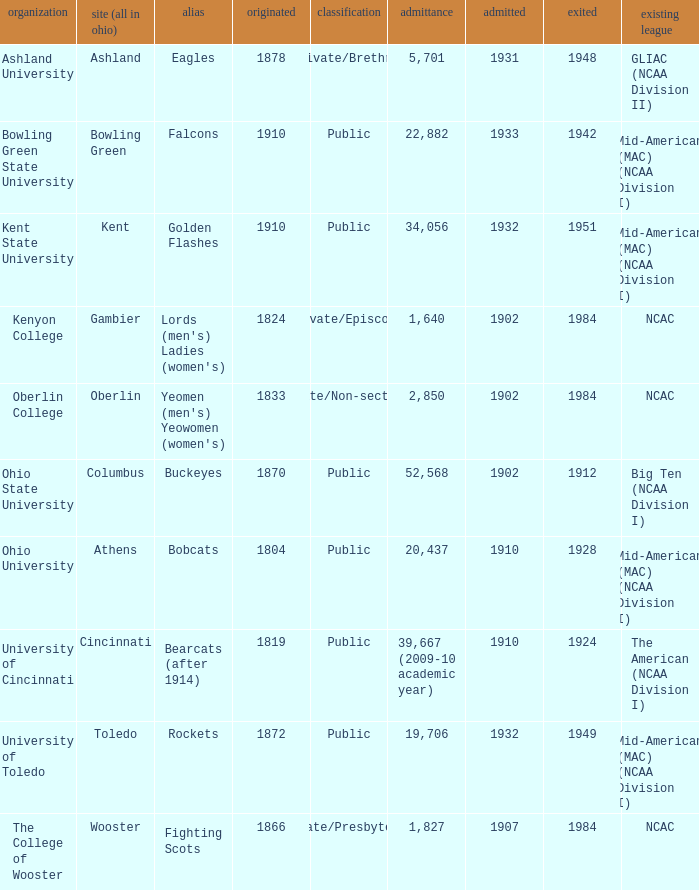Which founding year corresponds with the highest enrollment?  1910.0. 